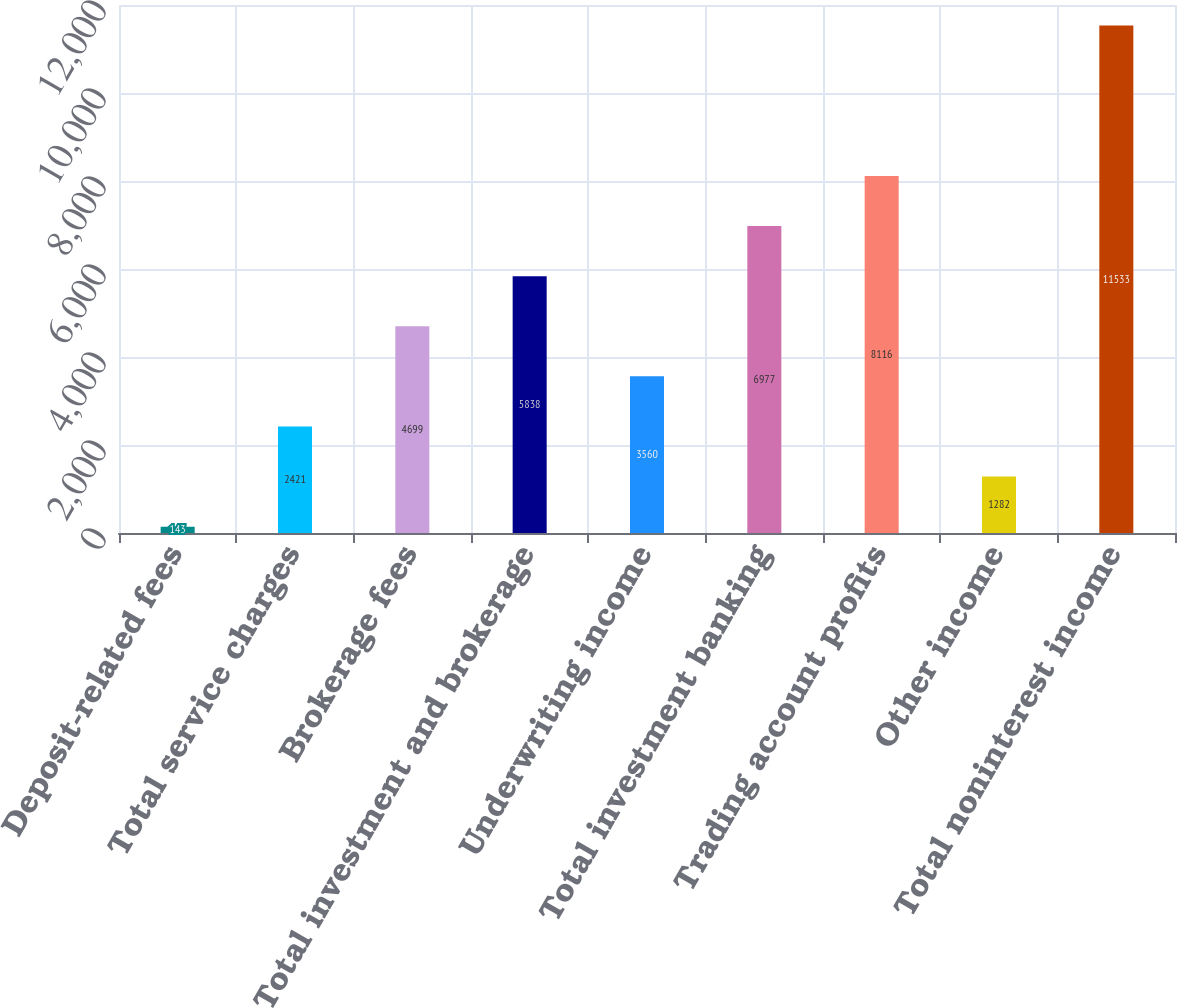<chart> <loc_0><loc_0><loc_500><loc_500><bar_chart><fcel>Deposit-related fees<fcel>Total service charges<fcel>Brokerage fees<fcel>Total investment and brokerage<fcel>Underwriting income<fcel>Total investment banking<fcel>Trading account profits<fcel>Other income<fcel>Total noninterest income<nl><fcel>143<fcel>2421<fcel>4699<fcel>5838<fcel>3560<fcel>6977<fcel>8116<fcel>1282<fcel>11533<nl></chart> 